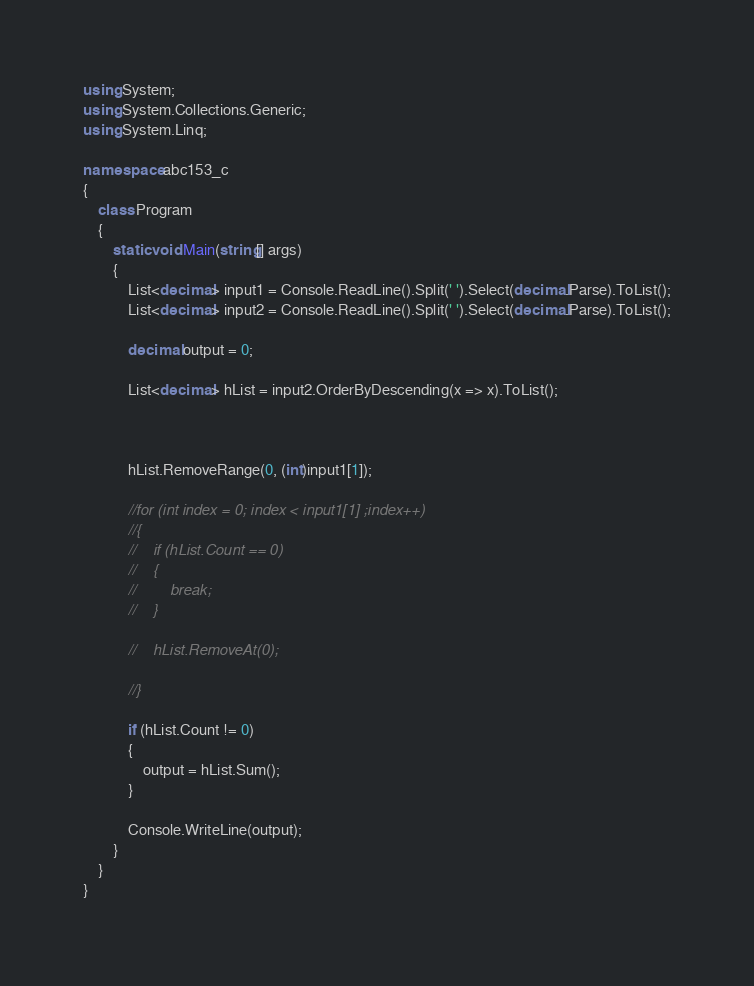<code> <loc_0><loc_0><loc_500><loc_500><_C#_>using System;
using System.Collections.Generic;
using System.Linq;

namespace abc153_c
{
    class Program
    {
        static void Main(string[] args)
        {
            List<decimal> input1 = Console.ReadLine().Split(' ').Select(decimal.Parse).ToList();
            List<decimal> input2 = Console.ReadLine().Split(' ').Select(decimal.Parse).ToList();

            decimal output = 0;

            List<decimal> hList = input2.OrderByDescending(x => x).ToList();



            hList.RemoveRange(0, (int)input1[1]);

            //for (int index = 0; index < input1[1] ;index++)
            //{
            //    if (hList.Count == 0)
            //    {
            //        break;
            //    }

            //    hList.RemoveAt(0);

            //}

            if (hList.Count != 0)
            {
                output = hList.Sum();
            }

            Console.WriteLine(output);
        }
    }
}
</code> 